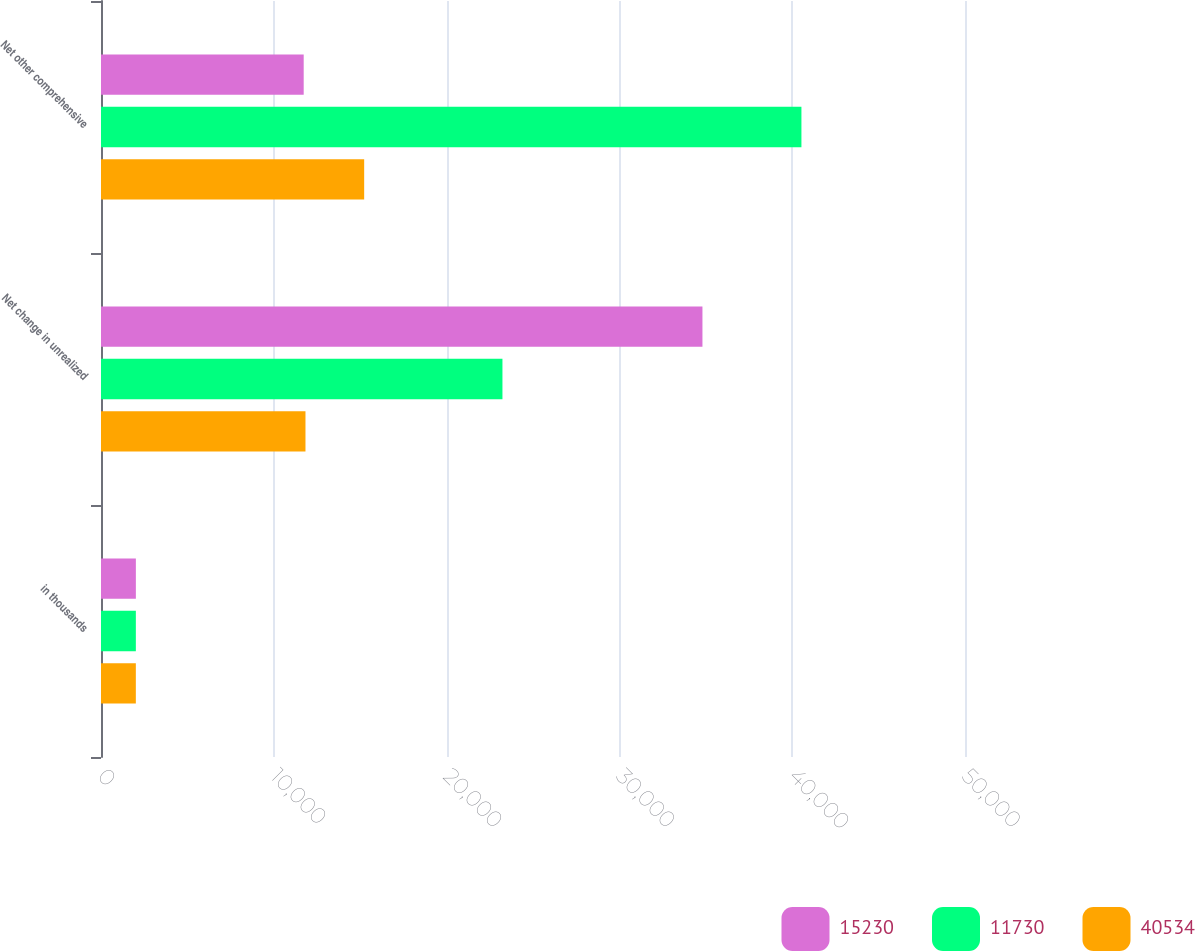Convert chart. <chart><loc_0><loc_0><loc_500><loc_500><stacked_bar_chart><ecel><fcel>in thousands<fcel>Net change in unrealized<fcel>Net other comprehensive<nl><fcel>15230<fcel>2018<fcel>34806<fcel>11730<nl><fcel>11730<fcel>2017<fcel>23232<fcel>40534<nl><fcel>40534<fcel>2016<fcel>11833<fcel>15230<nl></chart> 